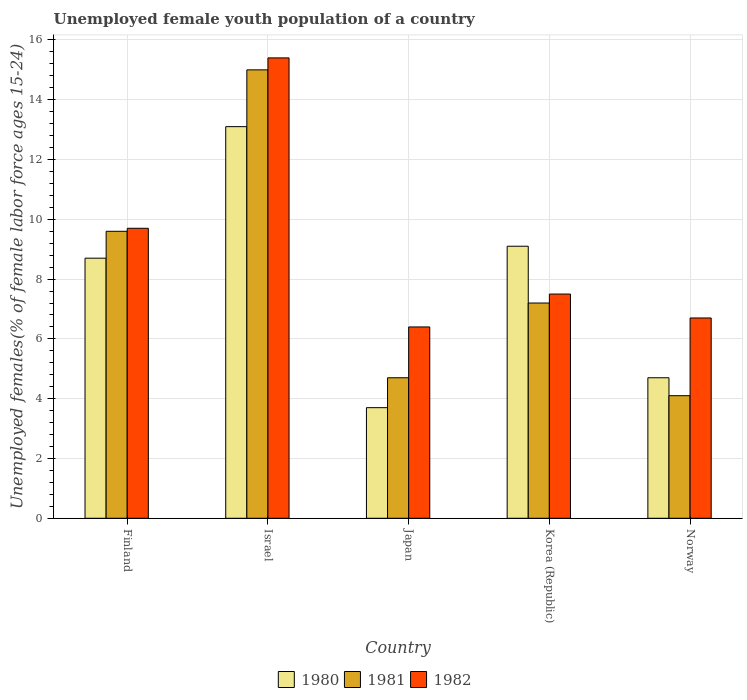How many bars are there on the 3rd tick from the left?
Provide a succinct answer. 3. How many bars are there on the 1st tick from the right?
Your answer should be very brief. 3. In how many cases, is the number of bars for a given country not equal to the number of legend labels?
Keep it short and to the point. 0. What is the percentage of unemployed female youth population in 1982 in Israel?
Make the answer very short. 15.4. Across all countries, what is the maximum percentage of unemployed female youth population in 1980?
Give a very brief answer. 13.1. Across all countries, what is the minimum percentage of unemployed female youth population in 1980?
Make the answer very short. 3.7. In which country was the percentage of unemployed female youth population in 1980 minimum?
Offer a terse response. Japan. What is the total percentage of unemployed female youth population in 1981 in the graph?
Give a very brief answer. 40.6. What is the difference between the percentage of unemployed female youth population in 1981 in Japan and that in Korea (Republic)?
Your answer should be compact. -2.5. What is the difference between the percentage of unemployed female youth population in 1982 in Norway and the percentage of unemployed female youth population in 1980 in Israel?
Your answer should be compact. -6.4. What is the average percentage of unemployed female youth population in 1982 per country?
Your answer should be compact. 9.14. What is the difference between the percentage of unemployed female youth population of/in 1981 and percentage of unemployed female youth population of/in 1980 in Norway?
Provide a short and direct response. -0.6. What is the ratio of the percentage of unemployed female youth population in 1981 in Israel to that in Japan?
Ensure brevity in your answer.  3.19. Is the percentage of unemployed female youth population in 1981 in Finland less than that in Korea (Republic)?
Ensure brevity in your answer.  No. What is the difference between the highest and the second highest percentage of unemployed female youth population in 1981?
Your response must be concise. 2.4. What is the difference between the highest and the lowest percentage of unemployed female youth population in 1982?
Offer a terse response. 9. In how many countries, is the percentage of unemployed female youth population in 1981 greater than the average percentage of unemployed female youth population in 1981 taken over all countries?
Keep it short and to the point. 2. Is the sum of the percentage of unemployed female youth population in 1980 in Israel and Korea (Republic) greater than the maximum percentage of unemployed female youth population in 1982 across all countries?
Provide a short and direct response. Yes. Is it the case that in every country, the sum of the percentage of unemployed female youth population in 1981 and percentage of unemployed female youth population in 1980 is greater than the percentage of unemployed female youth population in 1982?
Keep it short and to the point. Yes. Are all the bars in the graph horizontal?
Provide a succinct answer. No. How many countries are there in the graph?
Offer a very short reply. 5. What is the difference between two consecutive major ticks on the Y-axis?
Offer a very short reply. 2. Does the graph contain grids?
Provide a succinct answer. Yes. Where does the legend appear in the graph?
Make the answer very short. Bottom center. How many legend labels are there?
Give a very brief answer. 3. How are the legend labels stacked?
Your answer should be very brief. Horizontal. What is the title of the graph?
Offer a terse response. Unemployed female youth population of a country. Does "2005" appear as one of the legend labels in the graph?
Make the answer very short. No. What is the label or title of the Y-axis?
Make the answer very short. Unemployed females(% of female labor force ages 15-24). What is the Unemployed females(% of female labor force ages 15-24) in 1980 in Finland?
Offer a very short reply. 8.7. What is the Unemployed females(% of female labor force ages 15-24) of 1981 in Finland?
Make the answer very short. 9.6. What is the Unemployed females(% of female labor force ages 15-24) in 1982 in Finland?
Your response must be concise. 9.7. What is the Unemployed females(% of female labor force ages 15-24) of 1980 in Israel?
Give a very brief answer. 13.1. What is the Unemployed females(% of female labor force ages 15-24) in 1981 in Israel?
Offer a terse response. 15. What is the Unemployed females(% of female labor force ages 15-24) of 1982 in Israel?
Give a very brief answer. 15.4. What is the Unemployed females(% of female labor force ages 15-24) in 1980 in Japan?
Provide a short and direct response. 3.7. What is the Unemployed females(% of female labor force ages 15-24) in 1981 in Japan?
Your response must be concise. 4.7. What is the Unemployed females(% of female labor force ages 15-24) in 1982 in Japan?
Offer a very short reply. 6.4. What is the Unemployed females(% of female labor force ages 15-24) in 1980 in Korea (Republic)?
Offer a very short reply. 9.1. What is the Unemployed females(% of female labor force ages 15-24) in 1981 in Korea (Republic)?
Keep it short and to the point. 7.2. What is the Unemployed females(% of female labor force ages 15-24) in 1982 in Korea (Republic)?
Offer a terse response. 7.5. What is the Unemployed females(% of female labor force ages 15-24) of 1980 in Norway?
Give a very brief answer. 4.7. What is the Unemployed females(% of female labor force ages 15-24) in 1981 in Norway?
Provide a succinct answer. 4.1. What is the Unemployed females(% of female labor force ages 15-24) in 1982 in Norway?
Your response must be concise. 6.7. Across all countries, what is the maximum Unemployed females(% of female labor force ages 15-24) in 1980?
Offer a terse response. 13.1. Across all countries, what is the maximum Unemployed females(% of female labor force ages 15-24) of 1982?
Keep it short and to the point. 15.4. Across all countries, what is the minimum Unemployed females(% of female labor force ages 15-24) of 1980?
Make the answer very short. 3.7. Across all countries, what is the minimum Unemployed females(% of female labor force ages 15-24) of 1981?
Keep it short and to the point. 4.1. Across all countries, what is the minimum Unemployed females(% of female labor force ages 15-24) in 1982?
Ensure brevity in your answer.  6.4. What is the total Unemployed females(% of female labor force ages 15-24) of 1980 in the graph?
Offer a very short reply. 39.3. What is the total Unemployed females(% of female labor force ages 15-24) in 1981 in the graph?
Your answer should be compact. 40.6. What is the total Unemployed females(% of female labor force ages 15-24) of 1982 in the graph?
Keep it short and to the point. 45.7. What is the difference between the Unemployed females(% of female labor force ages 15-24) of 1980 in Finland and that in Israel?
Offer a terse response. -4.4. What is the difference between the Unemployed females(% of female labor force ages 15-24) of 1982 in Finland and that in Israel?
Make the answer very short. -5.7. What is the difference between the Unemployed females(% of female labor force ages 15-24) of 1981 in Finland and that in Japan?
Make the answer very short. 4.9. What is the difference between the Unemployed females(% of female labor force ages 15-24) of 1982 in Finland and that in Korea (Republic)?
Provide a succinct answer. 2.2. What is the difference between the Unemployed females(% of female labor force ages 15-24) in 1981 in Finland and that in Norway?
Ensure brevity in your answer.  5.5. What is the difference between the Unemployed females(% of female labor force ages 15-24) in 1982 in Finland and that in Norway?
Make the answer very short. 3. What is the difference between the Unemployed females(% of female labor force ages 15-24) of 1981 in Israel and that in Japan?
Keep it short and to the point. 10.3. What is the difference between the Unemployed females(% of female labor force ages 15-24) in 1981 in Israel and that in Norway?
Your answer should be very brief. 10.9. What is the difference between the Unemployed females(% of female labor force ages 15-24) of 1981 in Japan and that in Korea (Republic)?
Make the answer very short. -2.5. What is the difference between the Unemployed females(% of female labor force ages 15-24) of 1980 in Japan and that in Norway?
Keep it short and to the point. -1. What is the difference between the Unemployed females(% of female labor force ages 15-24) in 1982 in Japan and that in Norway?
Keep it short and to the point. -0.3. What is the difference between the Unemployed females(% of female labor force ages 15-24) in 1980 in Korea (Republic) and that in Norway?
Your answer should be very brief. 4.4. What is the difference between the Unemployed females(% of female labor force ages 15-24) in 1982 in Korea (Republic) and that in Norway?
Offer a terse response. 0.8. What is the difference between the Unemployed females(% of female labor force ages 15-24) of 1980 in Finland and the Unemployed females(% of female labor force ages 15-24) of 1982 in Israel?
Your answer should be compact. -6.7. What is the difference between the Unemployed females(% of female labor force ages 15-24) in 1981 in Finland and the Unemployed females(% of female labor force ages 15-24) in 1982 in Israel?
Provide a short and direct response. -5.8. What is the difference between the Unemployed females(% of female labor force ages 15-24) of 1980 in Finland and the Unemployed females(% of female labor force ages 15-24) of 1981 in Japan?
Offer a terse response. 4. What is the difference between the Unemployed females(% of female labor force ages 15-24) in 1980 in Finland and the Unemployed females(% of female labor force ages 15-24) in 1982 in Japan?
Offer a very short reply. 2.3. What is the difference between the Unemployed females(% of female labor force ages 15-24) of 1980 in Finland and the Unemployed females(% of female labor force ages 15-24) of 1981 in Korea (Republic)?
Provide a succinct answer. 1.5. What is the difference between the Unemployed females(% of female labor force ages 15-24) in 1980 in Finland and the Unemployed females(% of female labor force ages 15-24) in 1982 in Korea (Republic)?
Provide a short and direct response. 1.2. What is the difference between the Unemployed females(% of female labor force ages 15-24) of 1981 in Finland and the Unemployed females(% of female labor force ages 15-24) of 1982 in Norway?
Ensure brevity in your answer.  2.9. What is the difference between the Unemployed females(% of female labor force ages 15-24) in 1980 in Israel and the Unemployed females(% of female labor force ages 15-24) in 1981 in Japan?
Give a very brief answer. 8.4. What is the difference between the Unemployed females(% of female labor force ages 15-24) of 1981 in Israel and the Unemployed females(% of female labor force ages 15-24) of 1982 in Japan?
Offer a very short reply. 8.6. What is the difference between the Unemployed females(% of female labor force ages 15-24) in 1980 in Israel and the Unemployed females(% of female labor force ages 15-24) in 1981 in Korea (Republic)?
Your response must be concise. 5.9. What is the difference between the Unemployed females(% of female labor force ages 15-24) in 1981 in Israel and the Unemployed females(% of female labor force ages 15-24) in 1982 in Korea (Republic)?
Offer a terse response. 7.5. What is the difference between the Unemployed females(% of female labor force ages 15-24) of 1980 in Israel and the Unemployed females(% of female labor force ages 15-24) of 1982 in Norway?
Your response must be concise. 6.4. What is the difference between the Unemployed females(% of female labor force ages 15-24) of 1981 in Israel and the Unemployed females(% of female labor force ages 15-24) of 1982 in Norway?
Your answer should be compact. 8.3. What is the difference between the Unemployed females(% of female labor force ages 15-24) in 1980 in Japan and the Unemployed females(% of female labor force ages 15-24) in 1981 in Korea (Republic)?
Provide a short and direct response. -3.5. What is the difference between the Unemployed females(% of female labor force ages 15-24) of 1981 in Japan and the Unemployed females(% of female labor force ages 15-24) of 1982 in Korea (Republic)?
Keep it short and to the point. -2.8. What is the difference between the Unemployed females(% of female labor force ages 15-24) of 1980 in Japan and the Unemployed females(% of female labor force ages 15-24) of 1981 in Norway?
Provide a short and direct response. -0.4. What is the difference between the Unemployed females(% of female labor force ages 15-24) of 1980 in Japan and the Unemployed females(% of female labor force ages 15-24) of 1982 in Norway?
Provide a succinct answer. -3. What is the difference between the Unemployed females(% of female labor force ages 15-24) of 1981 in Japan and the Unemployed females(% of female labor force ages 15-24) of 1982 in Norway?
Your answer should be very brief. -2. What is the difference between the Unemployed females(% of female labor force ages 15-24) of 1980 in Korea (Republic) and the Unemployed females(% of female labor force ages 15-24) of 1982 in Norway?
Make the answer very short. 2.4. What is the difference between the Unemployed females(% of female labor force ages 15-24) of 1981 in Korea (Republic) and the Unemployed females(% of female labor force ages 15-24) of 1982 in Norway?
Keep it short and to the point. 0.5. What is the average Unemployed females(% of female labor force ages 15-24) of 1980 per country?
Provide a short and direct response. 7.86. What is the average Unemployed females(% of female labor force ages 15-24) in 1981 per country?
Your response must be concise. 8.12. What is the average Unemployed females(% of female labor force ages 15-24) in 1982 per country?
Keep it short and to the point. 9.14. What is the difference between the Unemployed females(% of female labor force ages 15-24) in 1980 and Unemployed females(% of female labor force ages 15-24) in 1982 in Finland?
Ensure brevity in your answer.  -1. What is the difference between the Unemployed females(% of female labor force ages 15-24) of 1981 and Unemployed females(% of female labor force ages 15-24) of 1982 in Finland?
Your answer should be very brief. -0.1. What is the difference between the Unemployed females(% of female labor force ages 15-24) in 1980 and Unemployed females(% of female labor force ages 15-24) in 1981 in Israel?
Your answer should be compact. -1.9. What is the difference between the Unemployed females(% of female labor force ages 15-24) of 1981 and Unemployed females(% of female labor force ages 15-24) of 1982 in Israel?
Give a very brief answer. -0.4. What is the difference between the Unemployed females(% of female labor force ages 15-24) in 1980 and Unemployed females(% of female labor force ages 15-24) in 1981 in Japan?
Provide a short and direct response. -1. What is the difference between the Unemployed females(% of female labor force ages 15-24) of 1981 and Unemployed females(% of female labor force ages 15-24) of 1982 in Norway?
Provide a short and direct response. -2.6. What is the ratio of the Unemployed females(% of female labor force ages 15-24) in 1980 in Finland to that in Israel?
Keep it short and to the point. 0.66. What is the ratio of the Unemployed females(% of female labor force ages 15-24) of 1981 in Finland to that in Israel?
Keep it short and to the point. 0.64. What is the ratio of the Unemployed females(% of female labor force ages 15-24) of 1982 in Finland to that in Israel?
Your answer should be very brief. 0.63. What is the ratio of the Unemployed females(% of female labor force ages 15-24) in 1980 in Finland to that in Japan?
Give a very brief answer. 2.35. What is the ratio of the Unemployed females(% of female labor force ages 15-24) in 1981 in Finland to that in Japan?
Your response must be concise. 2.04. What is the ratio of the Unemployed females(% of female labor force ages 15-24) of 1982 in Finland to that in Japan?
Give a very brief answer. 1.52. What is the ratio of the Unemployed females(% of female labor force ages 15-24) of 1980 in Finland to that in Korea (Republic)?
Your response must be concise. 0.96. What is the ratio of the Unemployed females(% of female labor force ages 15-24) in 1982 in Finland to that in Korea (Republic)?
Make the answer very short. 1.29. What is the ratio of the Unemployed females(% of female labor force ages 15-24) in 1980 in Finland to that in Norway?
Offer a very short reply. 1.85. What is the ratio of the Unemployed females(% of female labor force ages 15-24) in 1981 in Finland to that in Norway?
Ensure brevity in your answer.  2.34. What is the ratio of the Unemployed females(% of female labor force ages 15-24) of 1982 in Finland to that in Norway?
Ensure brevity in your answer.  1.45. What is the ratio of the Unemployed females(% of female labor force ages 15-24) in 1980 in Israel to that in Japan?
Your response must be concise. 3.54. What is the ratio of the Unemployed females(% of female labor force ages 15-24) in 1981 in Israel to that in Japan?
Your answer should be very brief. 3.19. What is the ratio of the Unemployed females(% of female labor force ages 15-24) in 1982 in Israel to that in Japan?
Provide a short and direct response. 2.41. What is the ratio of the Unemployed females(% of female labor force ages 15-24) in 1980 in Israel to that in Korea (Republic)?
Provide a short and direct response. 1.44. What is the ratio of the Unemployed females(% of female labor force ages 15-24) of 1981 in Israel to that in Korea (Republic)?
Provide a short and direct response. 2.08. What is the ratio of the Unemployed females(% of female labor force ages 15-24) of 1982 in Israel to that in Korea (Republic)?
Offer a terse response. 2.05. What is the ratio of the Unemployed females(% of female labor force ages 15-24) of 1980 in Israel to that in Norway?
Your response must be concise. 2.79. What is the ratio of the Unemployed females(% of female labor force ages 15-24) in 1981 in Israel to that in Norway?
Your answer should be very brief. 3.66. What is the ratio of the Unemployed females(% of female labor force ages 15-24) in 1982 in Israel to that in Norway?
Your response must be concise. 2.3. What is the ratio of the Unemployed females(% of female labor force ages 15-24) in 1980 in Japan to that in Korea (Republic)?
Keep it short and to the point. 0.41. What is the ratio of the Unemployed females(% of female labor force ages 15-24) of 1981 in Japan to that in Korea (Republic)?
Provide a succinct answer. 0.65. What is the ratio of the Unemployed females(% of female labor force ages 15-24) in 1982 in Japan to that in Korea (Republic)?
Your answer should be very brief. 0.85. What is the ratio of the Unemployed females(% of female labor force ages 15-24) of 1980 in Japan to that in Norway?
Ensure brevity in your answer.  0.79. What is the ratio of the Unemployed females(% of female labor force ages 15-24) in 1981 in Japan to that in Norway?
Offer a very short reply. 1.15. What is the ratio of the Unemployed females(% of female labor force ages 15-24) in 1982 in Japan to that in Norway?
Make the answer very short. 0.96. What is the ratio of the Unemployed females(% of female labor force ages 15-24) in 1980 in Korea (Republic) to that in Norway?
Give a very brief answer. 1.94. What is the ratio of the Unemployed females(% of female labor force ages 15-24) in 1981 in Korea (Republic) to that in Norway?
Your response must be concise. 1.76. What is the ratio of the Unemployed females(% of female labor force ages 15-24) in 1982 in Korea (Republic) to that in Norway?
Offer a terse response. 1.12. What is the difference between the highest and the second highest Unemployed females(% of female labor force ages 15-24) in 1980?
Your answer should be very brief. 4. What is the difference between the highest and the lowest Unemployed females(% of female labor force ages 15-24) of 1981?
Keep it short and to the point. 10.9. What is the difference between the highest and the lowest Unemployed females(% of female labor force ages 15-24) in 1982?
Your response must be concise. 9. 